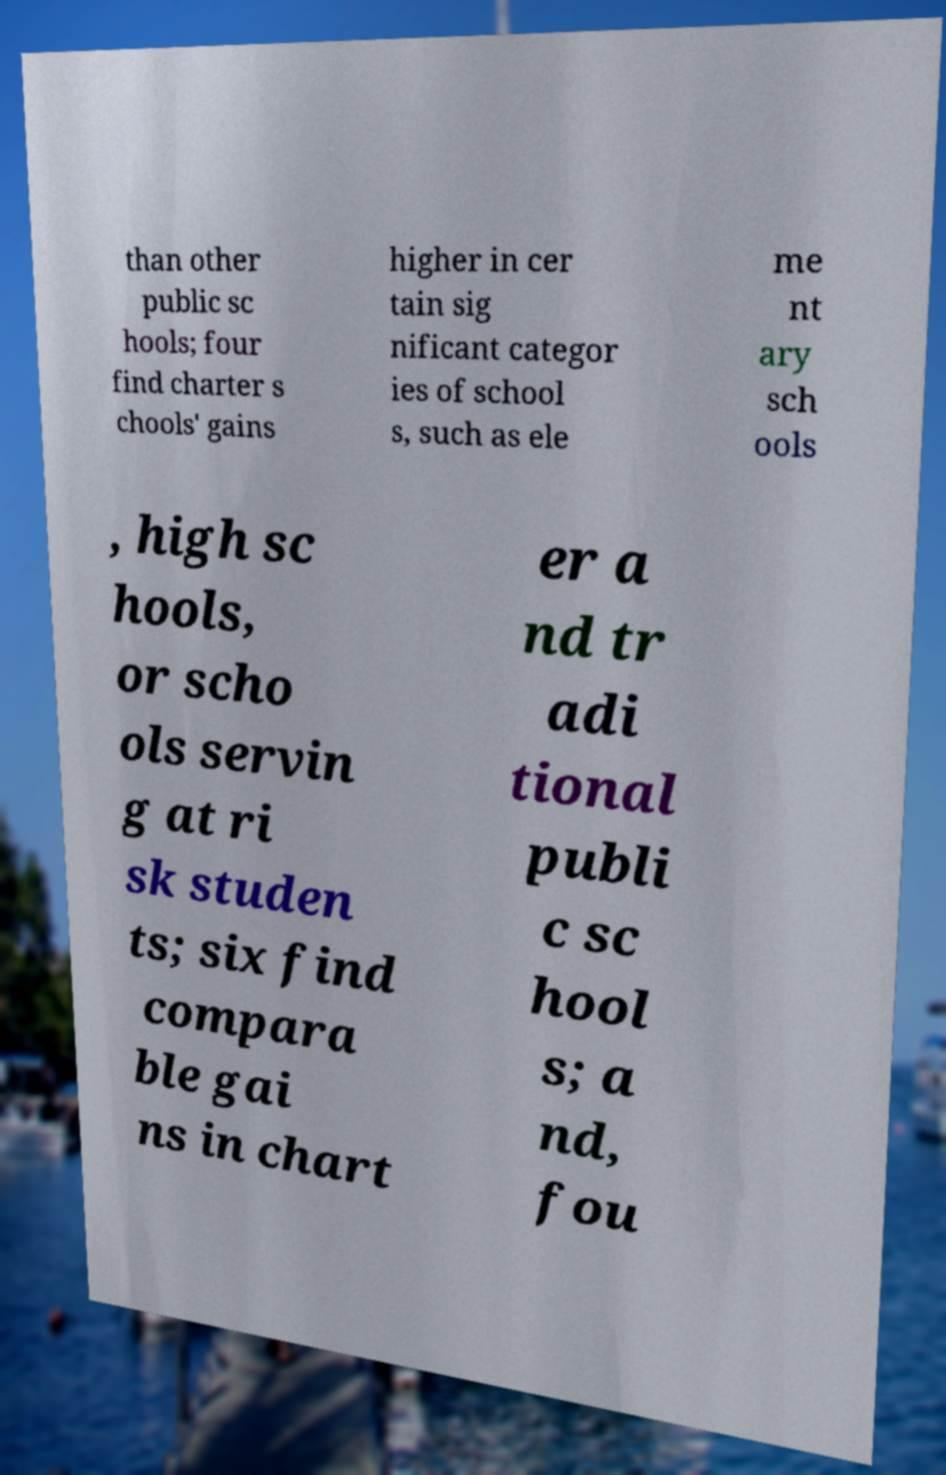For documentation purposes, I need the text within this image transcribed. Could you provide that? than other public sc hools; four find charter s chools' gains higher in cer tain sig nificant categor ies of school s, such as ele me nt ary sch ools , high sc hools, or scho ols servin g at ri sk studen ts; six find compara ble gai ns in chart er a nd tr adi tional publi c sc hool s; a nd, fou 